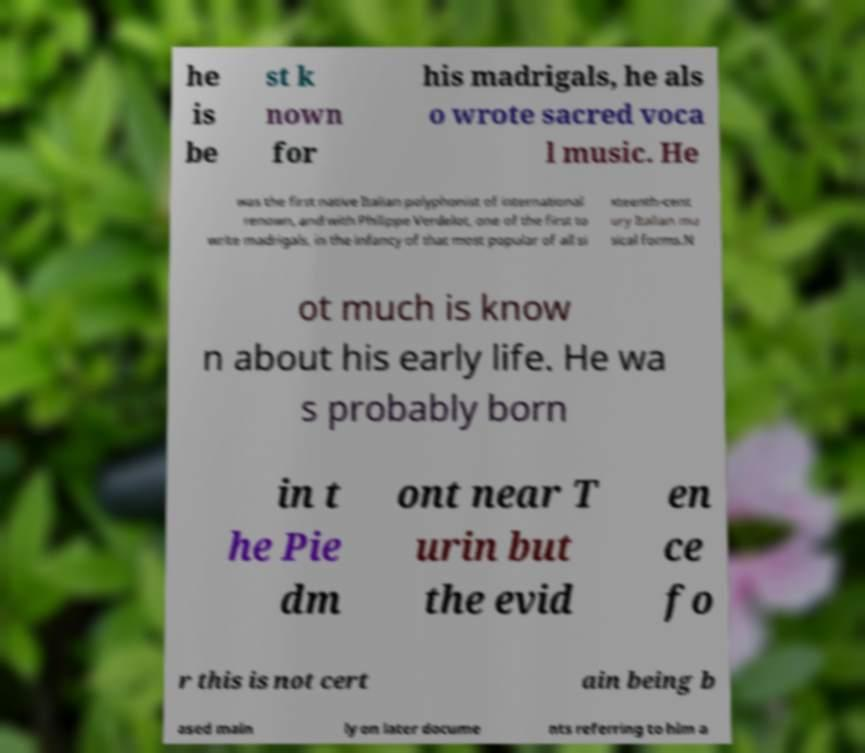Could you assist in decoding the text presented in this image and type it out clearly? he is be st k nown for his madrigals, he als o wrote sacred voca l music. He was the first native Italian polyphonist of international renown, and with Philippe Verdelot, one of the first to write madrigals, in the infancy of that most popular of all si xteenth-cent ury Italian mu sical forms.N ot much is know n about his early life. He wa s probably born in t he Pie dm ont near T urin but the evid en ce fo r this is not cert ain being b ased main ly on later docume nts referring to him a 